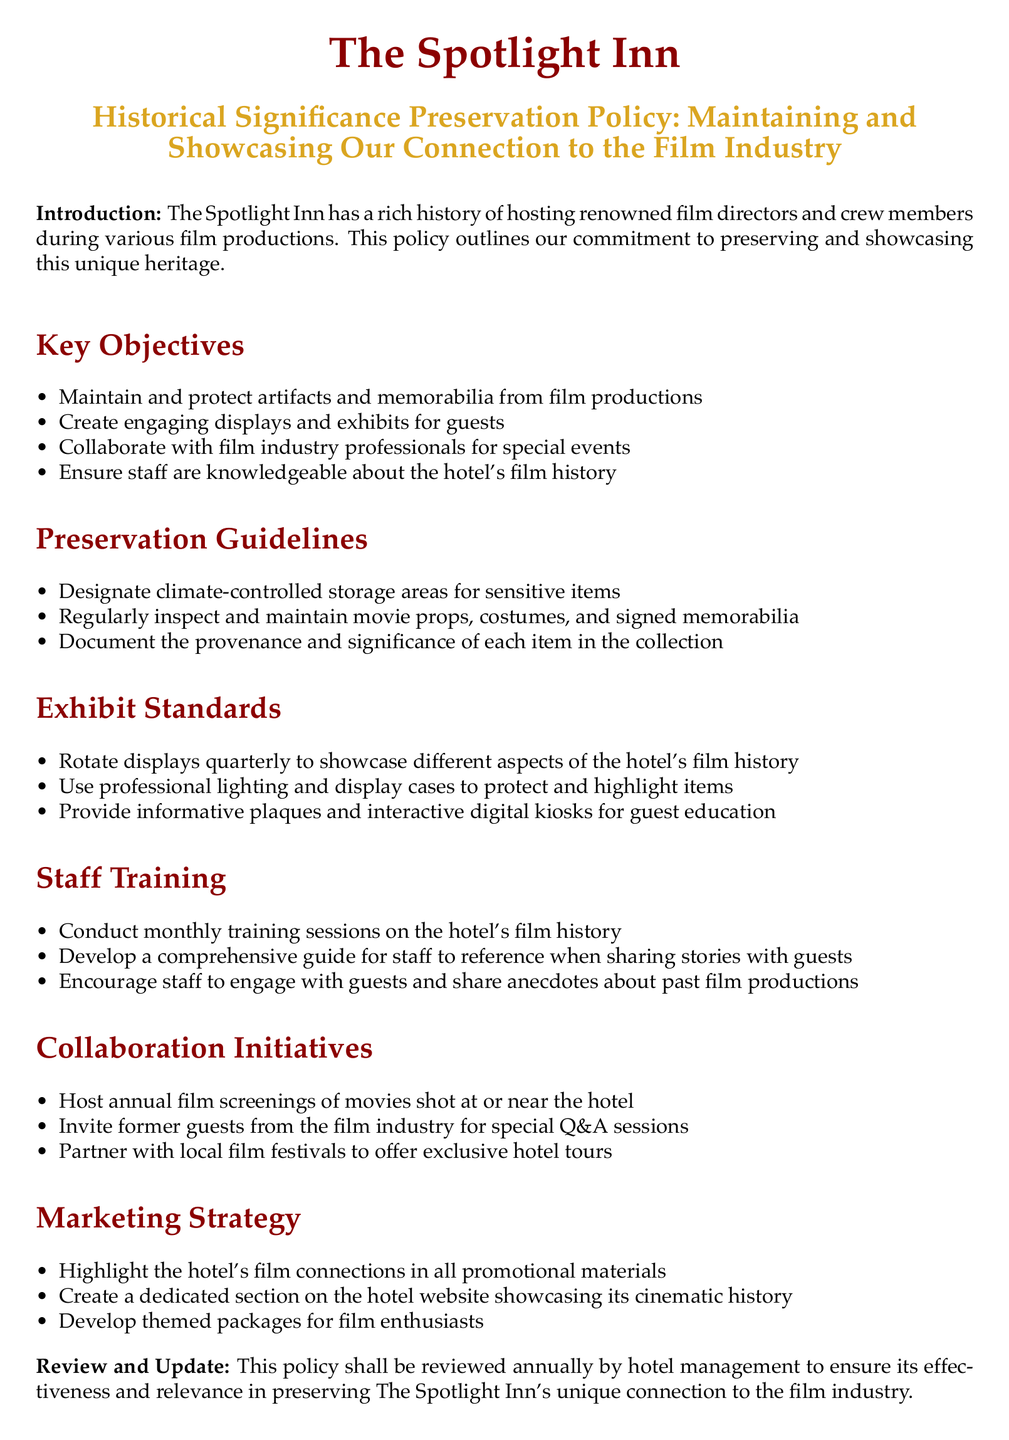What are the key objectives of the policy? The key objectives are outlined in a list format within the document, focusing on the hotel's commitment to film heritage.
Answer: Maintain and protect artifacts and memorabilia from film productions, Create engaging displays and exhibits for guests, Collaborate with film industry professionals for special events, Ensure staff are knowledgeable about the hotel's film history How often should displays be rotated? Display rotation is explicitly mentioned in the exhibit standards, indicating the frequency for showcasing different film history aspects.
Answer: Quarterly What type of training is conducted for staff? The document mentions training sessions designed to familiarize staff with the hotel's film history.
Answer: Monthly What is the designated storage for sensitive items? The preservation guidelines specify climate-controlled storage areas to protect sensitive artifacts and memorabilia.
Answer: Climate-controlled storage areas How often will the policy be reviewed? The document concludes with a statement about the frequency of policy reviews.
Answer: Annually 